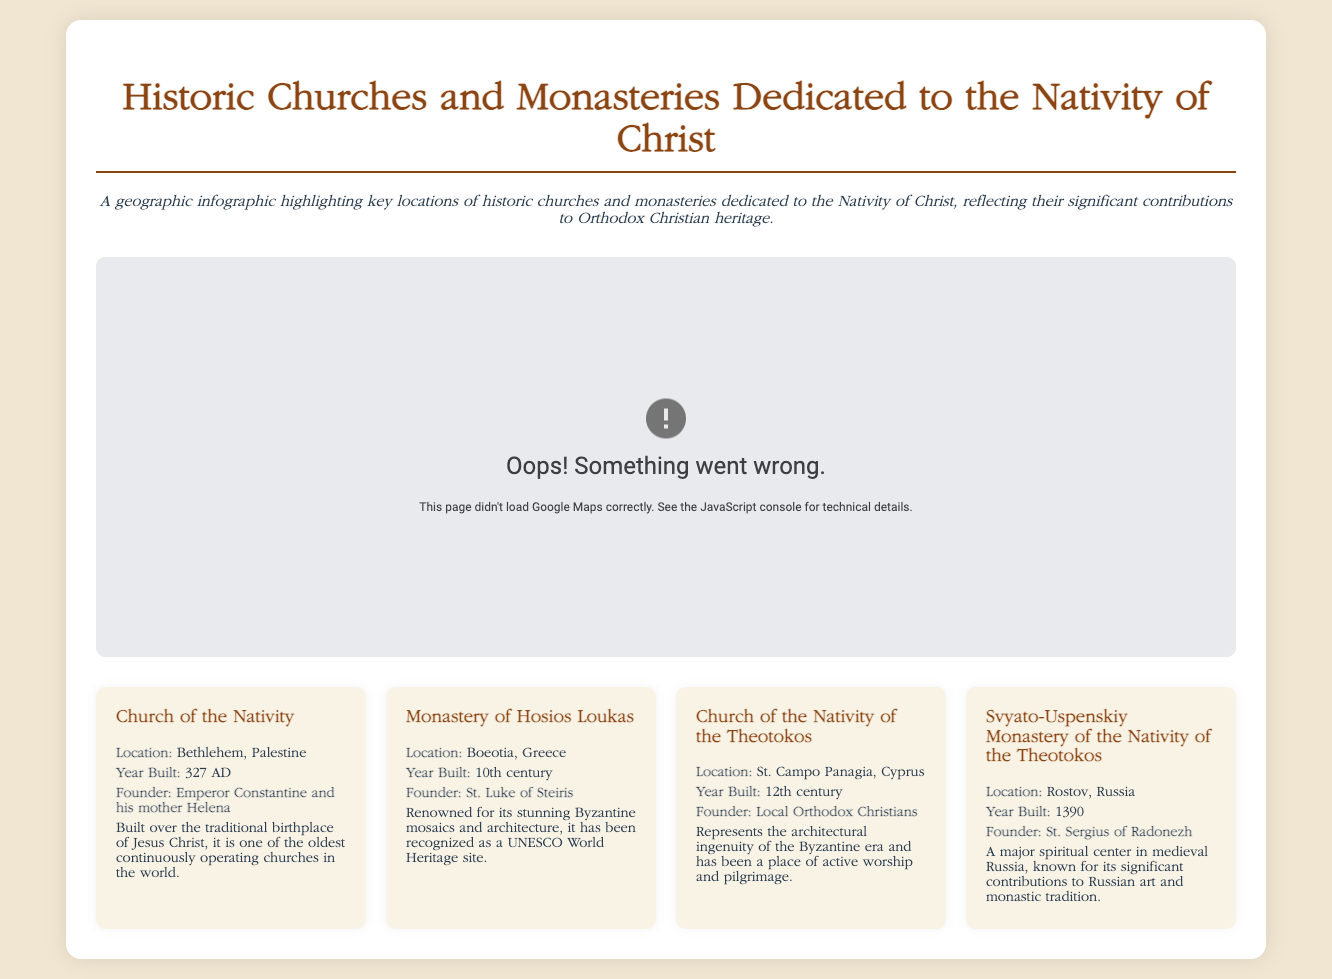what is the location of the Church of the Nativity? The Church of the Nativity is located in Bethlehem, Palestine.
Answer: Bethlehem, Palestine who founded the Monastery of Hosios Loukas? The Monastery of Hosios Loukas was founded by St. Luke of Steiris.
Answer: St. Luke of Steiris what year was the Church of the Nativity built? The Church of the Nativity was built in 327 AD.
Answer: 327 AD how many years ago was the Svyato-Uspenskiy Monastery built (considering 2023)? The Svyato-Uspenskiy Monastery was built in 1390, which is 633 years ago from 2023.
Answer: 633 years which location has been recognized as a UNESCO World Heritage site? The Monastery of Hosios Loukas has been recognized as a UNESCO World Heritage site.
Answer: Monastery of Hosios Loukas what is the architectural style of the Church of the Nativity of the Theotokos? The Church of the Nativity of the Theotokos represents the architectural ingenuity of the Byzantine era.
Answer: Byzantine era what distinguishes the Svyato-Uspenskiy Monastery of the Nativity of the Theotokos? It is known for its significant contributions to Russian art and monastic tradition.
Answer: Russian art and monastic tradition how is the map structured in this document? The map is structured to show key locations of historic churches and monasteries dedicated to the Nativity of Christ.
Answer: Key locations who were the founders of the Church of the Nativity? The Church of the Nativity was founded by Emperor Constantine and his mother Helena.
Answer: Emperor Constantine and his mother Helena 